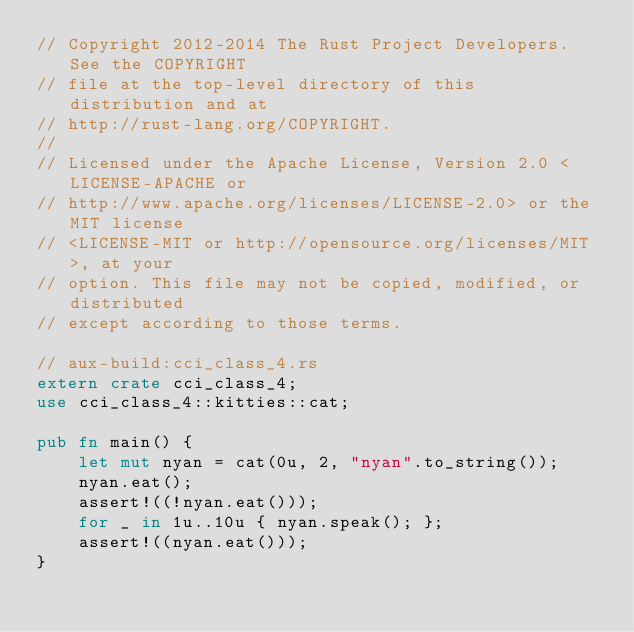Convert code to text. <code><loc_0><loc_0><loc_500><loc_500><_Rust_>// Copyright 2012-2014 The Rust Project Developers. See the COPYRIGHT
// file at the top-level directory of this distribution and at
// http://rust-lang.org/COPYRIGHT.
//
// Licensed under the Apache License, Version 2.0 <LICENSE-APACHE or
// http://www.apache.org/licenses/LICENSE-2.0> or the MIT license
// <LICENSE-MIT or http://opensource.org/licenses/MIT>, at your
// option. This file may not be copied, modified, or distributed
// except according to those terms.

// aux-build:cci_class_4.rs
extern crate cci_class_4;
use cci_class_4::kitties::cat;

pub fn main() {
    let mut nyan = cat(0u, 2, "nyan".to_string());
    nyan.eat();
    assert!((!nyan.eat()));
    for _ in 1u..10u { nyan.speak(); };
    assert!((nyan.eat()));
}
</code> 